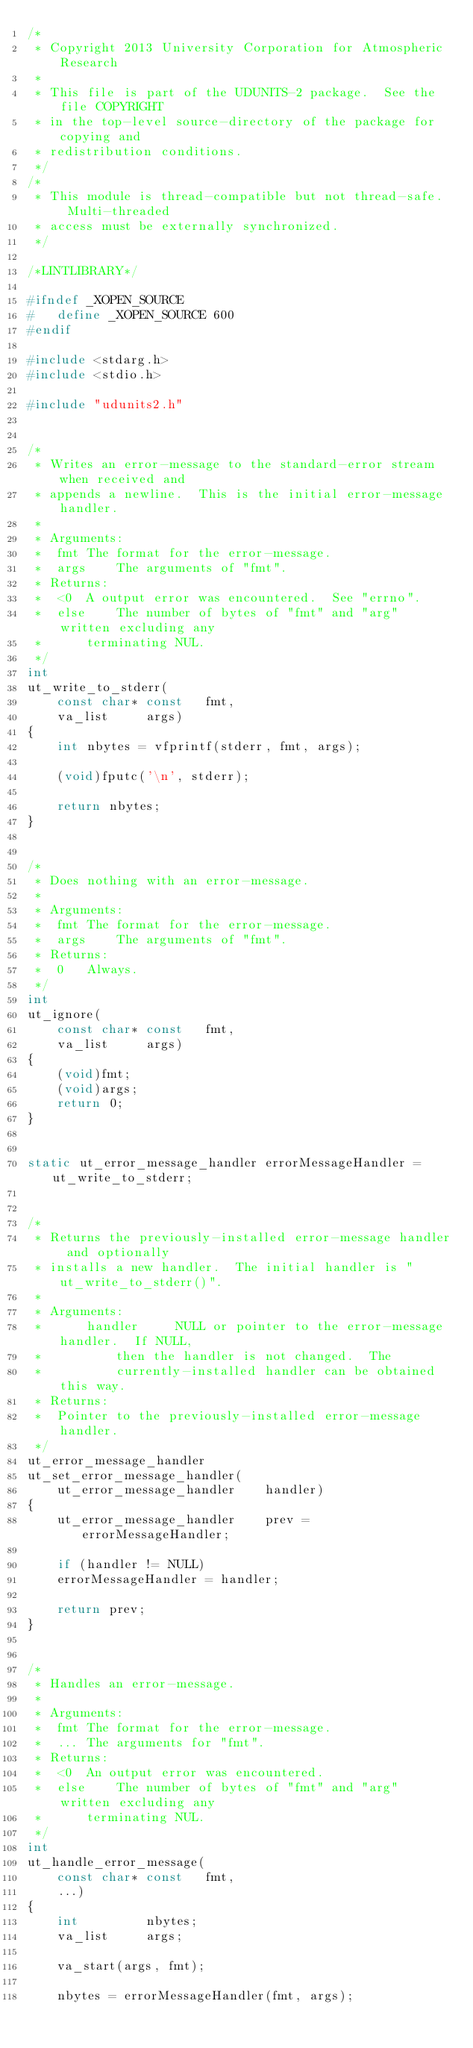Convert code to text. <code><loc_0><loc_0><loc_500><loc_500><_C_>/*
 * Copyright 2013 University Corporation for Atmospheric Research
 *
 * This file is part of the UDUNITS-2 package.  See the file COPYRIGHT
 * in the top-level source-directory of the package for copying and
 * redistribution conditions.
 */
/*
 * This module is thread-compatible but not thread-safe.  Multi-threaded
 * access must be externally synchronized.
 */

/*LINTLIBRARY*/

#ifndef	_XOPEN_SOURCE
#   define _XOPEN_SOURCE 600
#endif

#include <stdarg.h>
#include <stdio.h>

#include "udunits2.h"


/*
 * Writes an error-message to the standard-error stream when received and
 * appends a newline.  This is the initial error-message handler.
 *
 * Arguments:
 *	fmt	The format for the error-message.
 *	args	The arguments of "fmt".
 * Returns:
 *	<0	A output error was encountered.  See "errno".
 *	else	The number of bytes of "fmt" and "arg" written excluding any
 *		terminating NUL.
 */
int
ut_write_to_stderr(
    const char* const	fmt,
    va_list		args)
{
    int	nbytes = vfprintf(stderr, fmt, args);

    (void)fputc('\n', stderr);

    return nbytes;
}


/*
 * Does nothing with an error-message.
 *
 * Arguments:
 *	fmt	The format for the error-message.
 *	args	The arguments of "fmt".
 * Returns:
 *	0	Always.
 */
int
ut_ignore(
    const char* const	fmt,
    va_list		args)
{
    (void)fmt;
    (void)args;
    return 0;
}


static ut_error_message_handler	errorMessageHandler = ut_write_to_stderr;


/*
 * Returns the previously-installed error-message handler and optionally
 * installs a new handler.  The initial handler is "ut_write_to_stderr()".
 *
 * Arguments:
 *      handler		NULL or pointer to the error-message handler.  If NULL,
 *			then the handler is not changed.  The 
 *			currently-installed handler can be obtained this way.
 * Returns:
 *	Pointer to the previously-installed error-message handler.
 */
ut_error_message_handler
ut_set_error_message_handler(
    ut_error_message_handler	handler)
{
    ut_error_message_handler	prev = errorMessageHandler;

    if (handler != NULL)
	errorMessageHandler = handler;

    return prev;
}


/*
 * Handles an error-message.
 *
 * Arguments:
 *	fmt	The format for the error-message.
 *	...	The arguments for "fmt".
 * Returns:
 *	<0	An output error was encountered.
 *	else	The number of bytes of "fmt" and "arg" written excluding any
 *		terminating NUL.
 */
int
ut_handle_error_message(
    const char* const	fmt,
    ...)
{
    int			nbytes;
    va_list		args;

    va_start(args, fmt);

    nbytes = errorMessageHandler(fmt, args);
</code> 